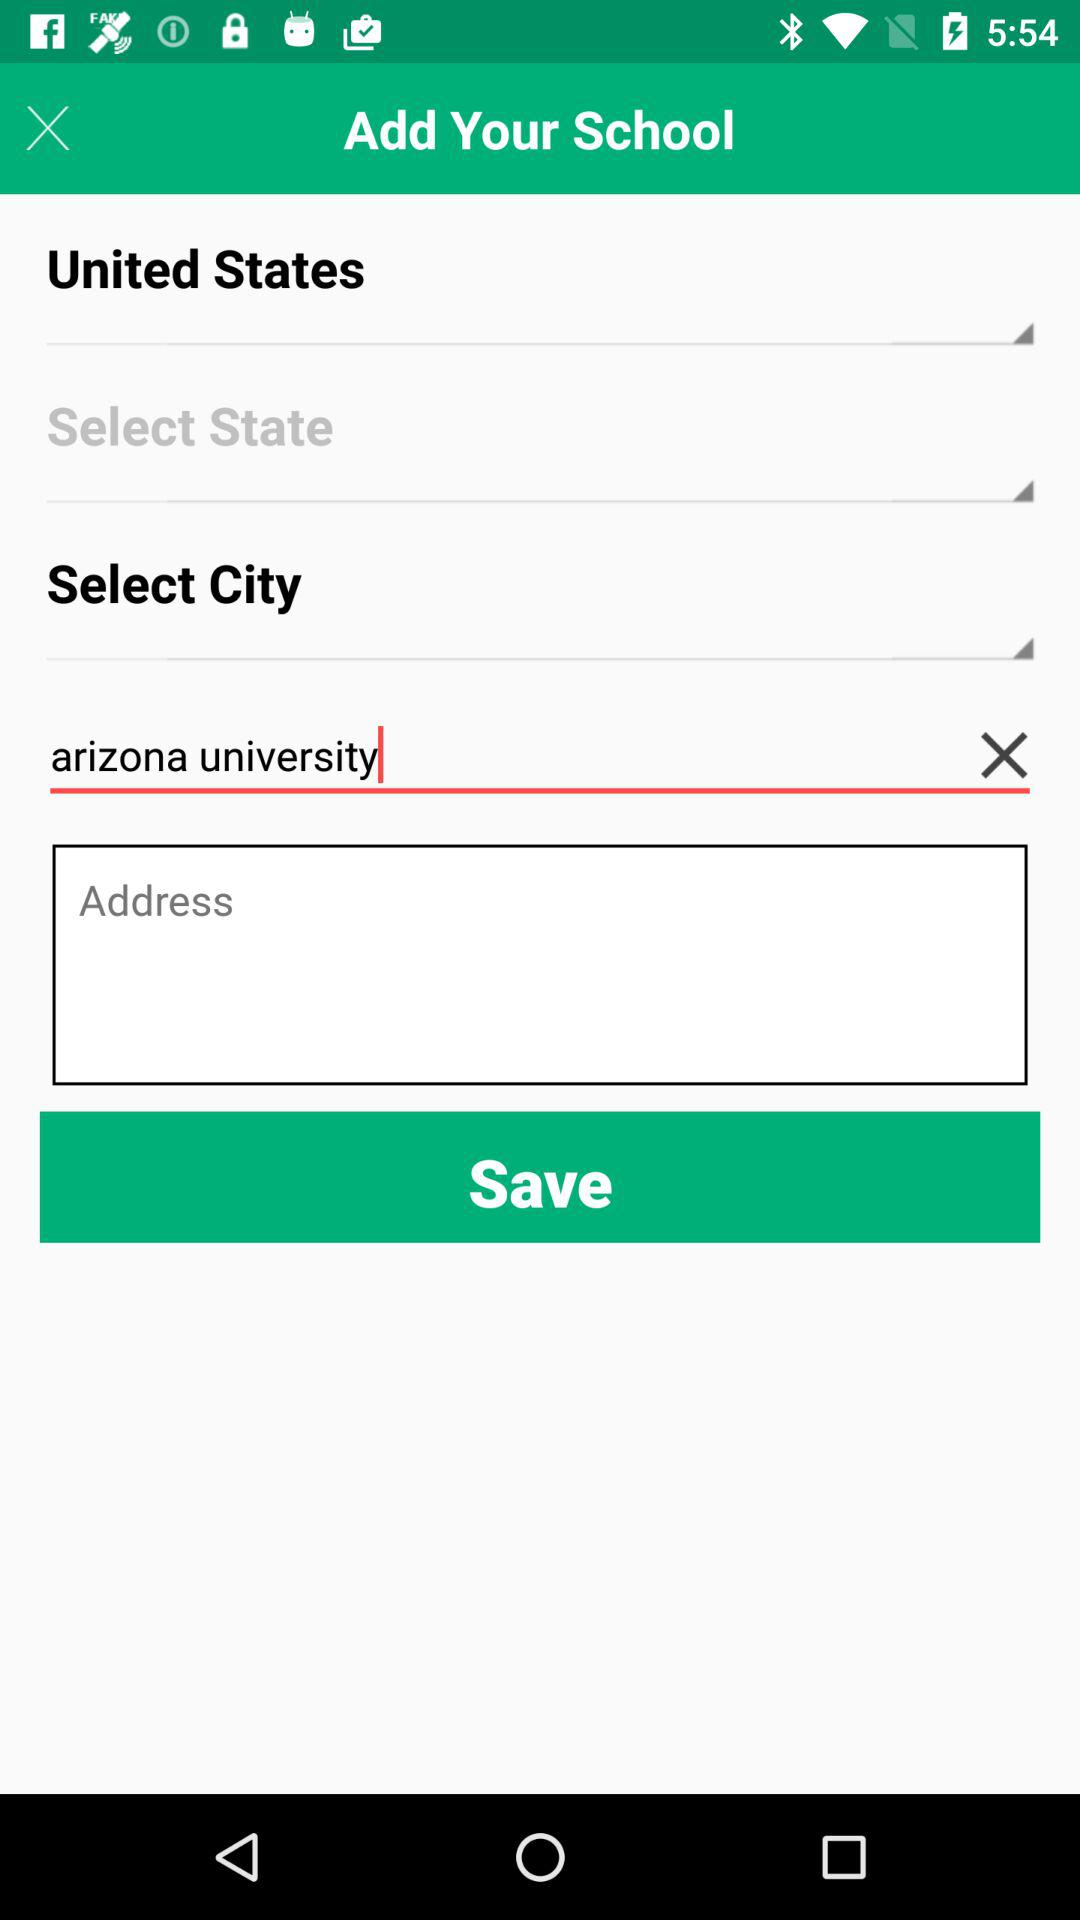What is the name of the university? The name of the university is "arizona university". 